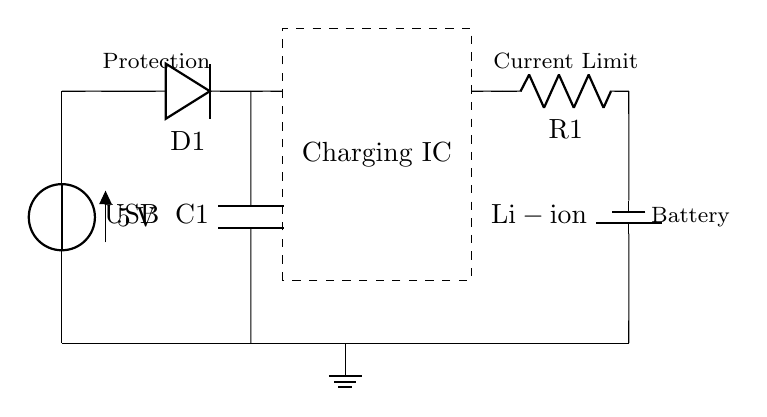What is the voltage source in this circuit? The voltage source is labeled as USB and provides a potential difference of 5 volts. This is indicated in the circuit diagram by the label next to the voltage source symbol.
Answer: USB, 5 volts What component provides protection to the circuit? The protection diode, labeled D1 in the circuit, is included to prevent reverse polarity or excessive voltage from damaging the components. Identifying the label next to the diode symbol confirms its function as protection.
Answer: D1 What is the role of capacitor C1 in this circuit? Capacitor C1 serves as an input capacitor, filtering and stabilizing the voltage supplied to the charging IC. This is deduced by looking at its position before the charging IC, ensuring smooth operation during charging.
Answer: Input filter How does the charging IC regulate the current to the battery? The charging IC, enclosed in a dashed rectangle, regulates the charging process by controlling the flow of current towards the lithium-ion battery. This is evident as it connects the USB source and the battery, acting as a facilitator of the charging current.
Answer: Current regulation What type of battery is being charged in this circuit? The circuit diagram specifies that a lithium-ion battery is represented by the label next to the battery symbol. This is the distinctive labeling that identifies the type of battery used in the diagram.
Answer: Lithium-ion How many resistors are shown in this circuit? The circuit includes a single resistor labeled R1, which is connected in series and typically used for current limiting or control. This can be identified by counting the resistive component symbol in the diagram.
Answer: One 